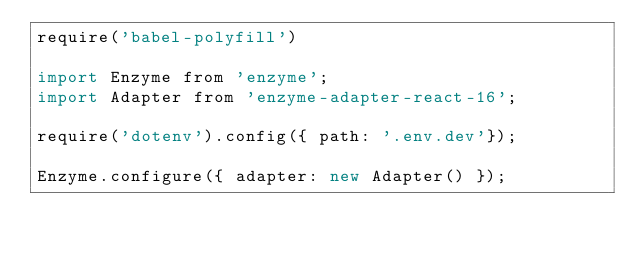Convert code to text. <code><loc_0><loc_0><loc_500><loc_500><_JavaScript_>require('babel-polyfill')

import Enzyme from 'enzyme';
import Adapter from 'enzyme-adapter-react-16';

require('dotenv').config({ path: '.env.dev'});

Enzyme.configure({ adapter: new Adapter() });
</code> 